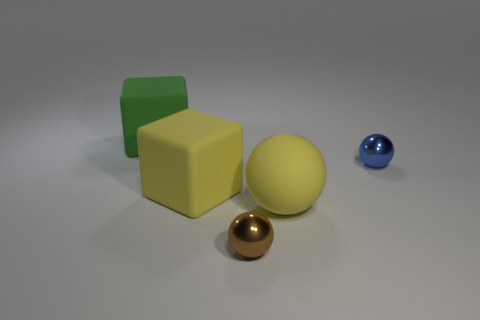Add 1 small blue spheres. How many objects exist? 6 Subtract all spheres. How many objects are left? 2 Add 5 large spheres. How many large spheres are left? 6 Add 4 tiny blue balls. How many tiny blue balls exist? 5 Subtract 0 cyan balls. How many objects are left? 5 Subtract all metallic balls. Subtract all small blue shiny balls. How many objects are left? 2 